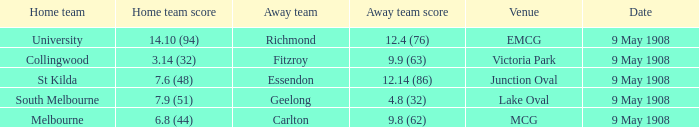Name the home team for carlton away team Melbourne. 